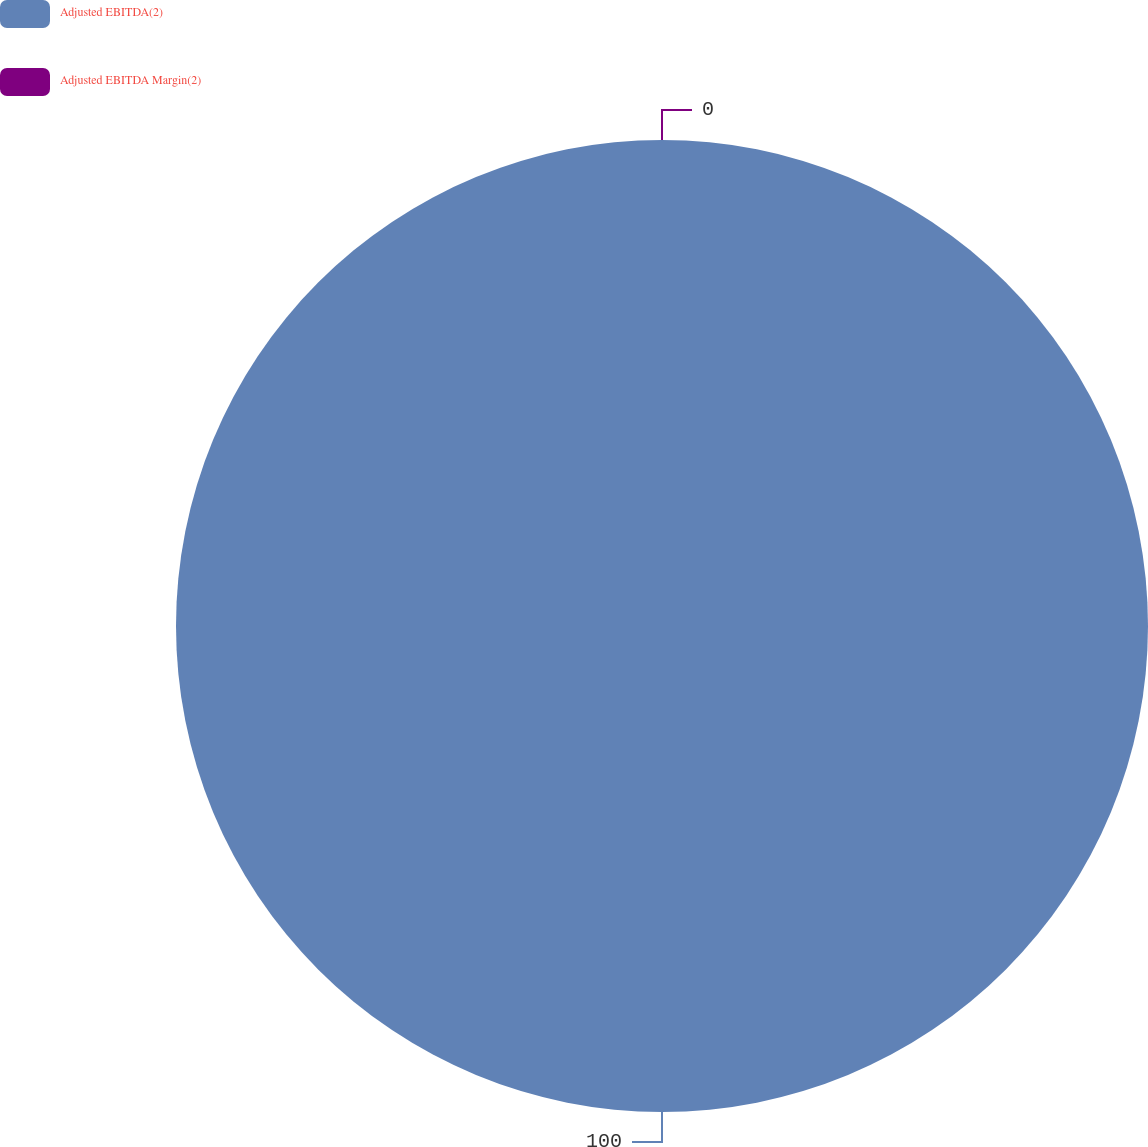Convert chart. <chart><loc_0><loc_0><loc_500><loc_500><pie_chart><fcel>Adjusted EBITDA(2)<fcel>Adjusted EBITDA Margin(2)<nl><fcel>100.0%<fcel>0.0%<nl></chart> 